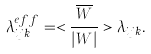Convert formula to latex. <formula><loc_0><loc_0><loc_500><loc_500>\lambda _ { i j k } ^ { e f f } = < \frac { \overline { W } } { | W | } > \lambda _ { i j k } .</formula> 